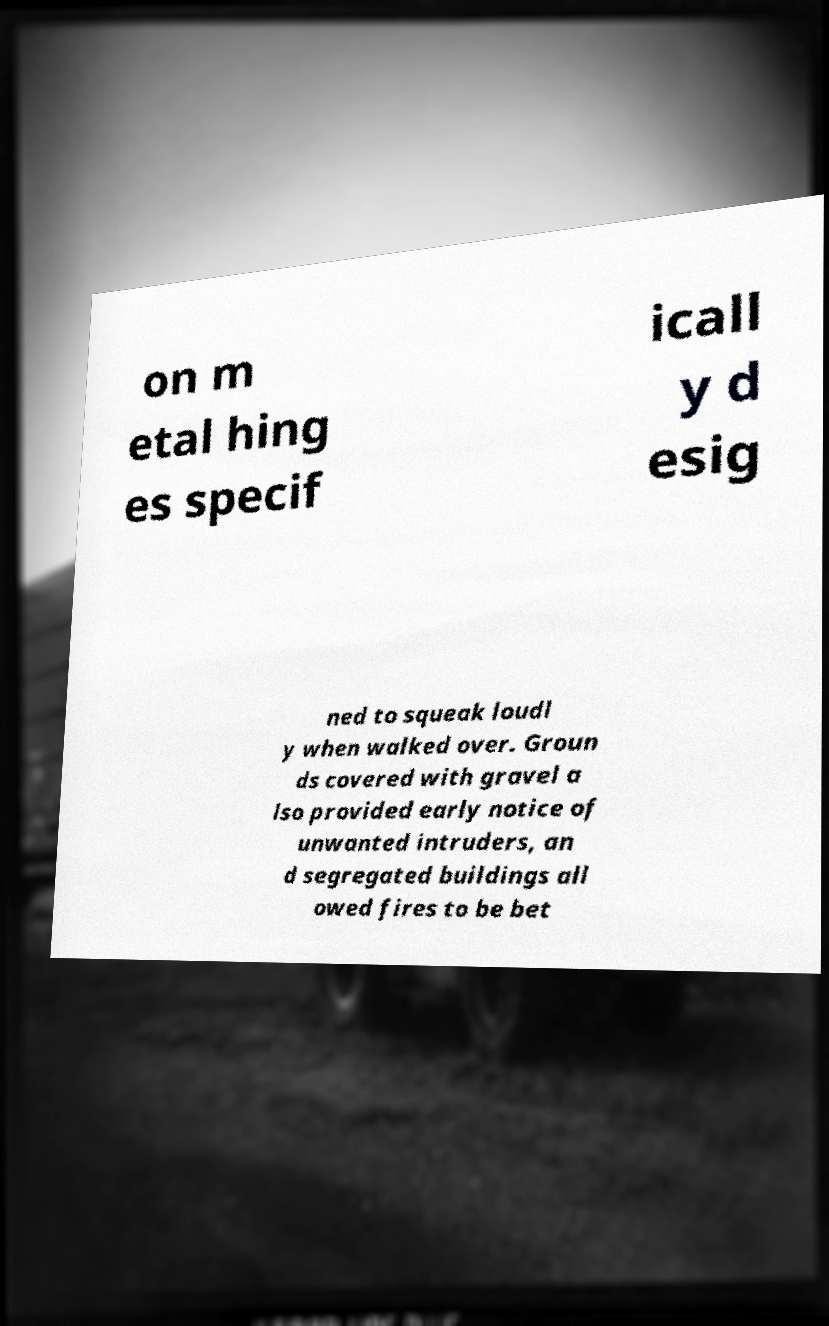What messages or text are displayed in this image? I need them in a readable, typed format. on m etal hing es specif icall y d esig ned to squeak loudl y when walked over. Groun ds covered with gravel a lso provided early notice of unwanted intruders, an d segregated buildings all owed fires to be bet 